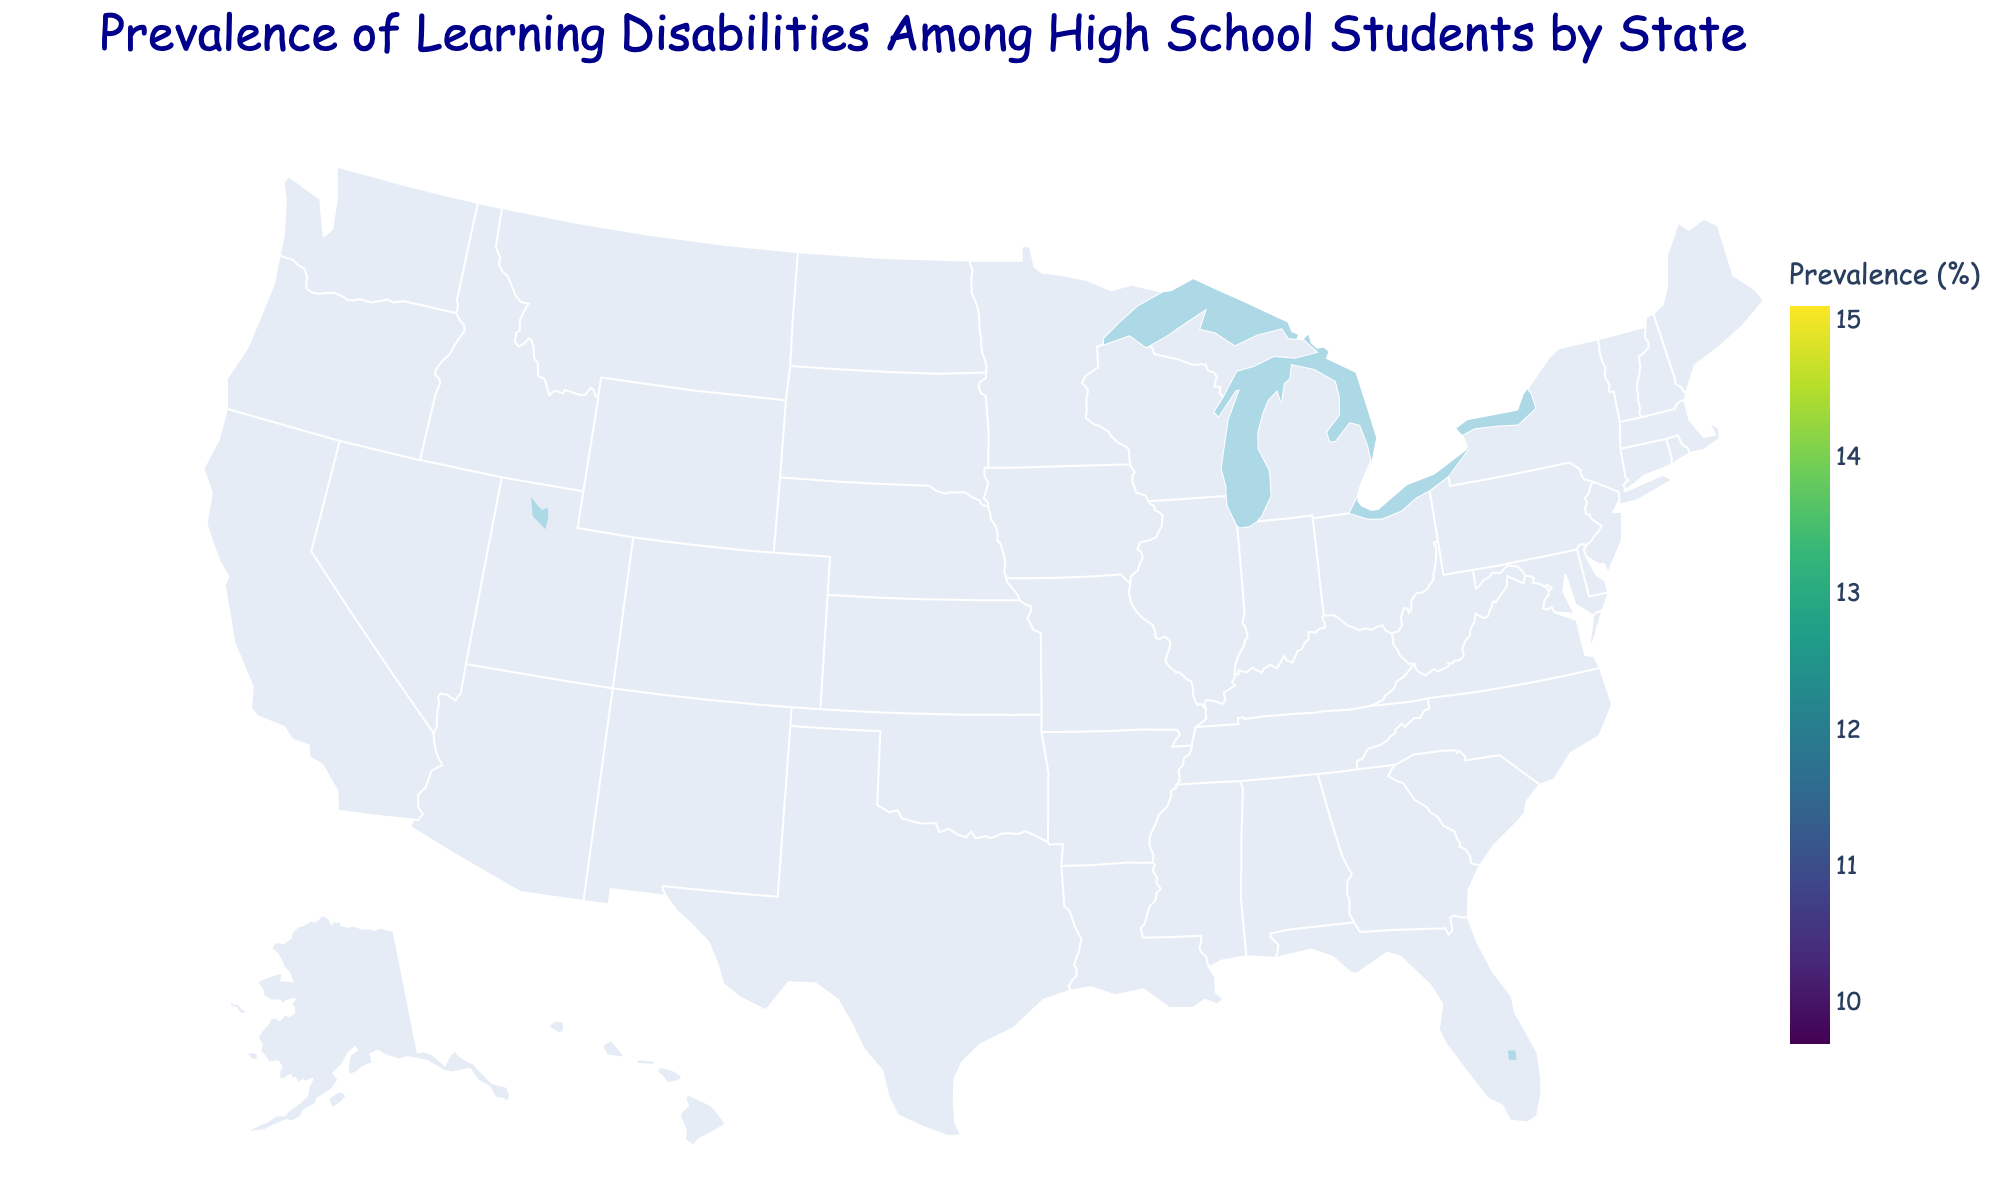What is the title of the figure? The title is usually displayed at the top of the figure, indicating the main topic or the content being visualized.
Answer: Prevalence of Learning Disabilities Among High School Students by State Which state has the highest prevalence of learning disabilities among high school students? To find this, look for the region on the map that is the darkest in color since the scale uses colors to indicate prevalence levels.
Answer: Kentucky Which state has the lowest prevalence of learning disabilities among high school students? Look for the lightest colored state on the map, as the lighter colors represent lower prevalence levels in the continuous scale.
Answer: California How does the prevalence of learning disabilities in Texas compare to that in New York? Identify Texas and New York on the map and compare the shades of color that represent their respective prevalence rates. New York should be darker than Texas.
Answer: New York has a higher prevalence than Texas What is the color scale used in the figure? Examine the color tones representing different prevalence levels in the legend on the side of the map.
Answer: Viridis Count how many states have a prevalence greater than 13%. Identify all states with darker colors that fall in the higher end of the scale (greater than 13%), and count them.
Answer: 13 states What states border Ohio, and what are their prevalence rates? First, locate Ohio on the map and then identify its neighboring states. Check the hover-over text or color scale for their respective prevalence rates.
Answer: Indiana (14.2%), Michigan (13.8%), Pennsylvania (14.1%), West Virginia (Not Listed), Kentucky (15.1%) What is the average prevalence of learning disabilities among high school students across all states? Sum all the prevalence rates provided in the data and divide by the number of states. (11.2 + 13.5 + ...) / 39 states
Answer: 12.59% Which states have a prevalence rate between 12% and 13%? Identify the states whose color falls in the middle of the color scale, which represents values between 12% and 13%.
Answer: Kansas, Minnesota, Missouri, Montana, New Jersey, South Carolina, Wyoming Which state has a prevalence rate closest to the median prevalence rate among all states? First, list all prevalence rates in ascending order. Find the middle value, and identify the state with the closest prevalence rate to that median value.
Answer: Minnesota 